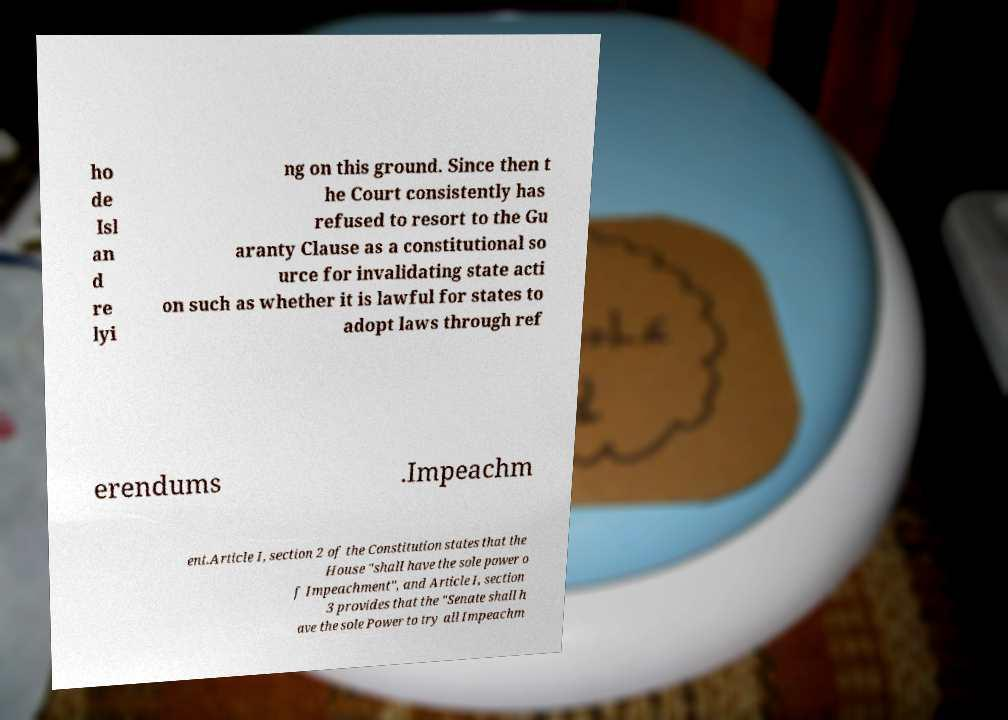What messages or text are displayed in this image? I need them in a readable, typed format. ho de Isl an d re lyi ng on this ground. Since then t he Court consistently has refused to resort to the Gu aranty Clause as a constitutional so urce for invalidating state acti on such as whether it is lawful for states to adopt laws through ref erendums .Impeachm ent.Article I, section 2 of the Constitution states that the House "shall have the sole power o f Impeachment", and Article I, section 3 provides that the "Senate shall h ave the sole Power to try all Impeachm 